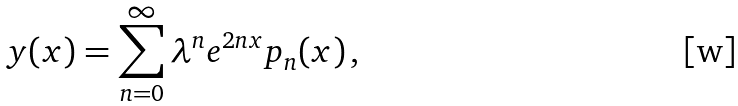<formula> <loc_0><loc_0><loc_500><loc_500>y ( x ) = \sum ^ { \infty } _ { n = 0 } \lambda ^ { n } e ^ { 2 n x } p _ { n } ( x ) \, ,</formula> 